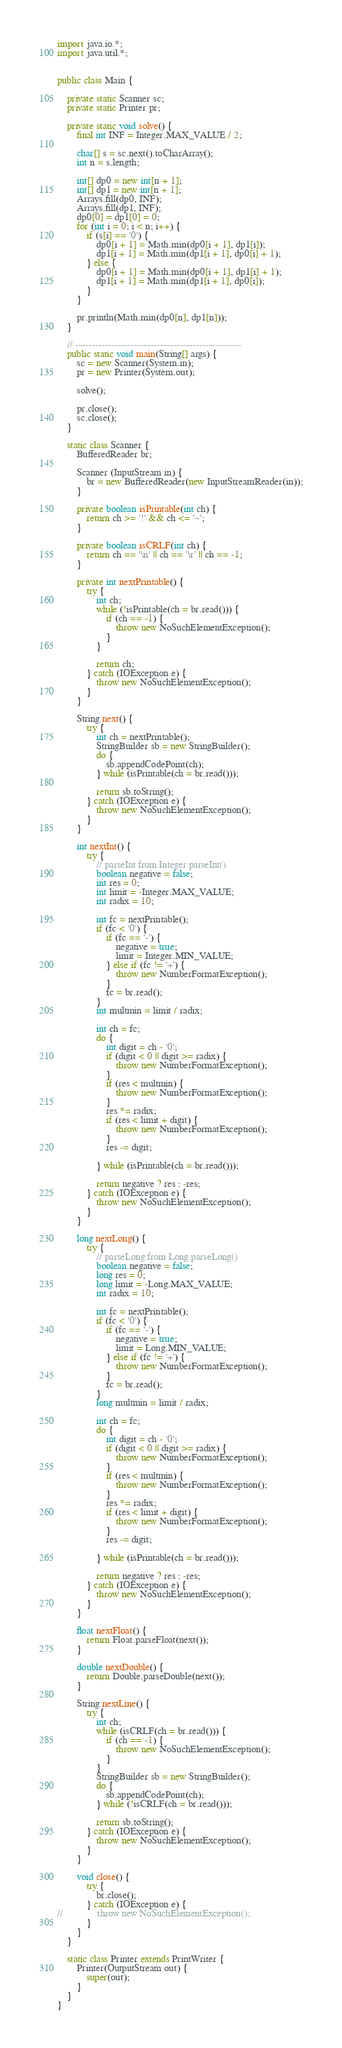Convert code to text. <code><loc_0><loc_0><loc_500><loc_500><_Java_>import java.io.*;
import java.util.*;


public class Main {

	private static Scanner sc;
	private static Printer pr;

	private static void solve() {
		final int INF = Integer.MAX_VALUE / 2;

		char[] s = sc.next().toCharArray();
		int n = s.length;

		int[] dp0 = new int[n + 1];
		int[] dp1 = new int[n + 1];
		Arrays.fill(dp0, INF);
		Arrays.fill(dp1, INF);
		dp0[0] = dp1[0] = 0;
		for (int i = 0; i < n; i++) {
			if (s[i] == '0') {
				dp0[i + 1] = Math.min(dp0[i + 1], dp1[i]);
				dp1[i + 1] = Math.min(dp1[i + 1], dp0[i] + 1);
			} else {
				dp0[i + 1] = Math.min(dp0[i + 1], dp1[i] + 1);
				dp1[i + 1] = Math.min(dp1[i + 1], dp0[i]);
			}
		}

		pr.println(Math.min(dp0[n], dp1[n]));
	}

	// ---------------------------------------------------
	public static void main(String[] args) {
		sc = new Scanner(System.in);
		pr = new Printer(System.out);
			
		solve();
			
		pr.close();
		sc.close();
	}

	static class Scanner {
		BufferedReader br;

		Scanner (InputStream in) {
			br = new BufferedReader(new InputStreamReader(in));
		}

		private boolean isPrintable(int ch) {
			return ch >= '!' && ch <= '~';
		}

		private boolean isCRLF(int ch) {
			return ch == '\n' || ch == '\r' || ch == -1;
		}

		private int nextPrintable() {
			try {
				int ch;
				while (!isPrintable(ch = br.read())) {
					if (ch == -1) {
						throw new NoSuchElementException();
					}
				}

				return ch;
			} catch (IOException e) {
				throw new NoSuchElementException();
			}
		}

		String next() {
			try {
				int ch = nextPrintable();
				StringBuilder sb = new StringBuilder();
				do {
					sb.appendCodePoint(ch);
				} while (isPrintable(ch = br.read()));

				return sb.toString();
			} catch (IOException e) {
				throw new NoSuchElementException();
			}
		}

		int nextInt() {
			try {
				// parseInt from Integer.parseInt()
				boolean negative = false;
				int res = 0;
				int limit = -Integer.MAX_VALUE;
				int radix = 10;

				int fc = nextPrintable();
				if (fc < '0') {
					if (fc == '-') {
						negative = true;
						limit = Integer.MIN_VALUE;
					} else if (fc != '+') {
						throw new NumberFormatException();
					}
					fc = br.read();
				}
				int multmin = limit / radix;

				int ch = fc;
				do {
					int digit = ch - '0';
					if (digit < 0 || digit >= radix) {
						throw new NumberFormatException();
					}
					if (res < multmin) {
						throw new NumberFormatException();
					}
					res *= radix;
					if (res < limit + digit) {
						throw new NumberFormatException();
					}
					res -= digit;

				} while (isPrintable(ch = br.read()));

				return negative ? res : -res;
			} catch (IOException e) {
				throw new NoSuchElementException();
			}
		}

		long nextLong() {
			try {
				// parseLong from Long.parseLong()
				boolean negative = false;
				long res = 0;
				long limit = -Long.MAX_VALUE;
				int radix = 10;

				int fc = nextPrintable();
				if (fc < '0') {
					if (fc == '-') {
						negative = true;
						limit = Long.MIN_VALUE;
					} else if (fc != '+') {
						throw new NumberFormatException();
					}
					fc = br.read();
				}
				long multmin = limit / radix;

				int ch = fc;
				do {
					int digit = ch - '0';
					if (digit < 0 || digit >= radix) {
						throw new NumberFormatException();
					}
					if (res < multmin) {
						throw new NumberFormatException();
					}
					res *= radix;
					if (res < limit + digit) {
						throw new NumberFormatException();
					}
					res -= digit;

				} while (isPrintable(ch = br.read()));

				return negative ? res : -res;
			} catch (IOException e) {
				throw new NoSuchElementException();
			}
		}

		float nextFloat() {
			return Float.parseFloat(next());
		}

		double nextDouble() {
			return Double.parseDouble(next());
		}

		String nextLine() {
			try {
				int ch;
				while (isCRLF(ch = br.read())) {
					if (ch == -1) {
						throw new NoSuchElementException();
					}
				}
				StringBuilder sb = new StringBuilder();
				do {
					sb.appendCodePoint(ch);
				} while (!isCRLF(ch = br.read()));

				return sb.toString();
			} catch (IOException e) {
				throw new NoSuchElementException();
			}
		}

		void close() {
			try {
				br.close();
			} catch (IOException e) {
//				throw new NoSuchElementException();
			}
		}
	}

	static class Printer extends PrintWriter {
		Printer(OutputStream out) {
			super(out);
		}
	}
}
</code> 